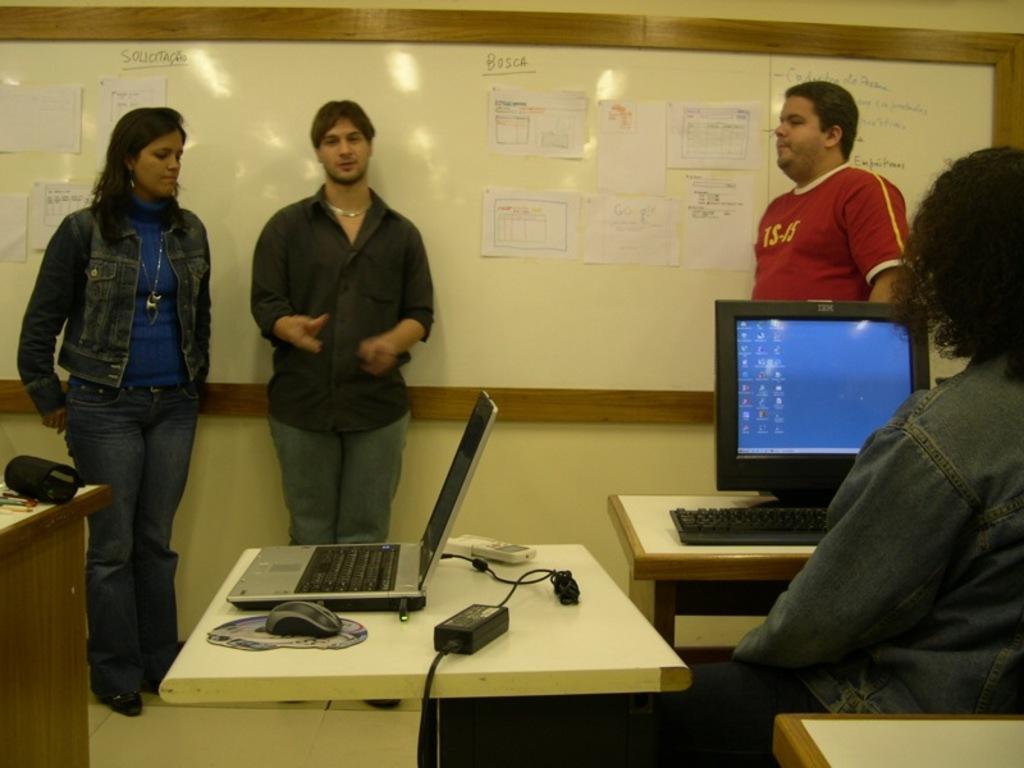Describe this image in one or two sentences. In this image, few peoples are stand near the white board. Right side, human is sat in-front of monitor and keyboard. There is a wooden tables in the image. Few items are placed on it. 